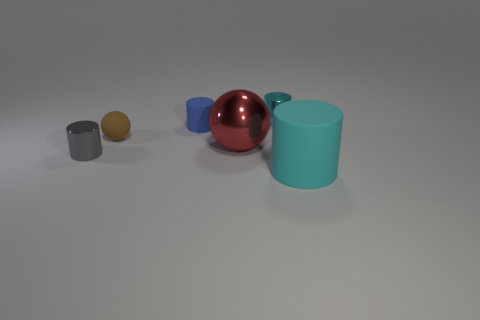What number of objects are big cylinders or large brown rubber balls?
Provide a short and direct response. 1. What size is the gray cylinder?
Offer a terse response. Small. Is the number of big cyan things less than the number of green balls?
Your answer should be very brief. No. What number of large balls have the same color as the tiny sphere?
Offer a very short reply. 0. Do the small shiny object on the right side of the small gray shiny cylinder and the big rubber object have the same color?
Your answer should be very brief. Yes. There is a small rubber object that is on the right side of the tiny brown ball; what is its shape?
Make the answer very short. Cylinder. Are there any tiny gray metallic things in front of the small metal object behind the small rubber cylinder?
Provide a short and direct response. Yes. How many tiny gray objects have the same material as the large red ball?
Offer a very short reply. 1. There is a matte cylinder right of the rubber cylinder to the left of the matte object to the right of the tiny blue object; what size is it?
Keep it short and to the point. Large. How many large shiny balls are to the right of the brown thing?
Make the answer very short. 1. 